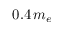Convert formula to latex. <formula><loc_0><loc_0><loc_500><loc_500>0 . 4 \, { m _ { e } }</formula> 